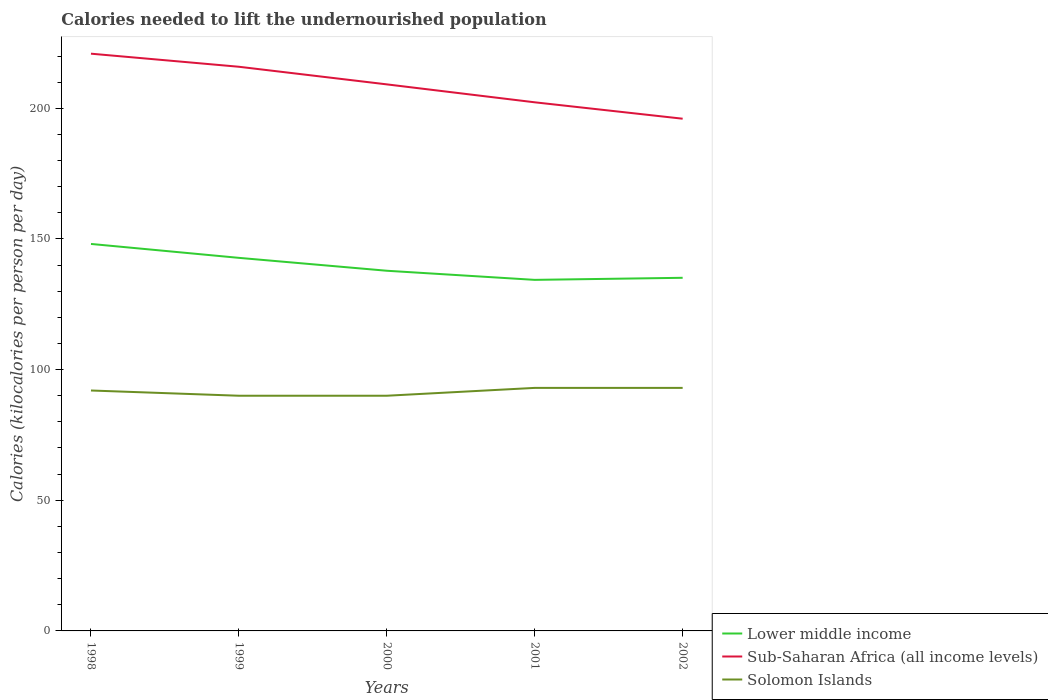Across all years, what is the maximum total calories needed to lift the undernourished population in Solomon Islands?
Provide a short and direct response. 90. What is the total total calories needed to lift the undernourished population in Sub-Saharan Africa (all income levels) in the graph?
Provide a succinct answer. 13.6. What is the difference between the highest and the second highest total calories needed to lift the undernourished population in Lower middle income?
Offer a very short reply. 13.74. Is the total calories needed to lift the undernourished population in Lower middle income strictly greater than the total calories needed to lift the undernourished population in Solomon Islands over the years?
Offer a terse response. No. How many lines are there?
Your answer should be compact. 3. How many years are there in the graph?
Your answer should be compact. 5. What is the difference between two consecutive major ticks on the Y-axis?
Your response must be concise. 50. Where does the legend appear in the graph?
Your response must be concise. Bottom right. How are the legend labels stacked?
Ensure brevity in your answer.  Vertical. What is the title of the graph?
Provide a short and direct response. Calories needed to lift the undernourished population. What is the label or title of the X-axis?
Your answer should be compact. Years. What is the label or title of the Y-axis?
Give a very brief answer. Calories (kilocalories per person per day). What is the Calories (kilocalories per person per day) in Lower middle income in 1998?
Give a very brief answer. 148.08. What is the Calories (kilocalories per person per day) in Sub-Saharan Africa (all income levels) in 1998?
Give a very brief answer. 220.89. What is the Calories (kilocalories per person per day) in Solomon Islands in 1998?
Offer a very short reply. 92. What is the Calories (kilocalories per person per day) in Lower middle income in 1999?
Give a very brief answer. 142.76. What is the Calories (kilocalories per person per day) of Sub-Saharan Africa (all income levels) in 1999?
Ensure brevity in your answer.  215.89. What is the Calories (kilocalories per person per day) in Solomon Islands in 1999?
Offer a very short reply. 90. What is the Calories (kilocalories per person per day) in Lower middle income in 2000?
Offer a terse response. 137.83. What is the Calories (kilocalories per person per day) in Sub-Saharan Africa (all income levels) in 2000?
Offer a very short reply. 209.15. What is the Calories (kilocalories per person per day) of Lower middle income in 2001?
Ensure brevity in your answer.  134.34. What is the Calories (kilocalories per person per day) in Sub-Saharan Africa (all income levels) in 2001?
Your answer should be compact. 202.29. What is the Calories (kilocalories per person per day) in Solomon Islands in 2001?
Offer a terse response. 93. What is the Calories (kilocalories per person per day) of Lower middle income in 2002?
Your response must be concise. 135.13. What is the Calories (kilocalories per person per day) of Sub-Saharan Africa (all income levels) in 2002?
Provide a short and direct response. 196.01. What is the Calories (kilocalories per person per day) of Solomon Islands in 2002?
Ensure brevity in your answer.  93. Across all years, what is the maximum Calories (kilocalories per person per day) of Lower middle income?
Ensure brevity in your answer.  148.08. Across all years, what is the maximum Calories (kilocalories per person per day) in Sub-Saharan Africa (all income levels)?
Your answer should be very brief. 220.89. Across all years, what is the maximum Calories (kilocalories per person per day) of Solomon Islands?
Ensure brevity in your answer.  93. Across all years, what is the minimum Calories (kilocalories per person per day) of Lower middle income?
Offer a very short reply. 134.34. Across all years, what is the minimum Calories (kilocalories per person per day) of Sub-Saharan Africa (all income levels)?
Make the answer very short. 196.01. What is the total Calories (kilocalories per person per day) of Lower middle income in the graph?
Provide a succinct answer. 698.13. What is the total Calories (kilocalories per person per day) of Sub-Saharan Africa (all income levels) in the graph?
Ensure brevity in your answer.  1044.22. What is the total Calories (kilocalories per person per day) in Solomon Islands in the graph?
Keep it short and to the point. 458. What is the difference between the Calories (kilocalories per person per day) in Lower middle income in 1998 and that in 1999?
Provide a short and direct response. 5.32. What is the difference between the Calories (kilocalories per person per day) in Sub-Saharan Africa (all income levels) in 1998 and that in 1999?
Your answer should be very brief. 5.01. What is the difference between the Calories (kilocalories per person per day) in Solomon Islands in 1998 and that in 1999?
Your answer should be very brief. 2. What is the difference between the Calories (kilocalories per person per day) in Lower middle income in 1998 and that in 2000?
Offer a very short reply. 10.26. What is the difference between the Calories (kilocalories per person per day) in Sub-Saharan Africa (all income levels) in 1998 and that in 2000?
Give a very brief answer. 11.75. What is the difference between the Calories (kilocalories per person per day) in Lower middle income in 1998 and that in 2001?
Your response must be concise. 13.74. What is the difference between the Calories (kilocalories per person per day) in Sub-Saharan Africa (all income levels) in 1998 and that in 2001?
Make the answer very short. 18.61. What is the difference between the Calories (kilocalories per person per day) in Lower middle income in 1998 and that in 2002?
Your answer should be compact. 12.95. What is the difference between the Calories (kilocalories per person per day) in Sub-Saharan Africa (all income levels) in 1998 and that in 2002?
Provide a succinct answer. 24.89. What is the difference between the Calories (kilocalories per person per day) of Lower middle income in 1999 and that in 2000?
Offer a terse response. 4.94. What is the difference between the Calories (kilocalories per person per day) of Sub-Saharan Africa (all income levels) in 1999 and that in 2000?
Ensure brevity in your answer.  6.74. What is the difference between the Calories (kilocalories per person per day) of Solomon Islands in 1999 and that in 2000?
Make the answer very short. 0. What is the difference between the Calories (kilocalories per person per day) of Lower middle income in 1999 and that in 2001?
Keep it short and to the point. 8.42. What is the difference between the Calories (kilocalories per person per day) of Sub-Saharan Africa (all income levels) in 1999 and that in 2001?
Provide a short and direct response. 13.6. What is the difference between the Calories (kilocalories per person per day) in Solomon Islands in 1999 and that in 2001?
Keep it short and to the point. -3. What is the difference between the Calories (kilocalories per person per day) in Lower middle income in 1999 and that in 2002?
Your answer should be compact. 7.63. What is the difference between the Calories (kilocalories per person per day) in Sub-Saharan Africa (all income levels) in 1999 and that in 2002?
Offer a very short reply. 19.88. What is the difference between the Calories (kilocalories per person per day) of Lower middle income in 2000 and that in 2001?
Give a very brief answer. 3.49. What is the difference between the Calories (kilocalories per person per day) of Sub-Saharan Africa (all income levels) in 2000 and that in 2001?
Give a very brief answer. 6.86. What is the difference between the Calories (kilocalories per person per day) in Lower middle income in 2000 and that in 2002?
Offer a terse response. 2.7. What is the difference between the Calories (kilocalories per person per day) in Sub-Saharan Africa (all income levels) in 2000 and that in 2002?
Make the answer very short. 13.14. What is the difference between the Calories (kilocalories per person per day) of Solomon Islands in 2000 and that in 2002?
Keep it short and to the point. -3. What is the difference between the Calories (kilocalories per person per day) of Lower middle income in 2001 and that in 2002?
Ensure brevity in your answer.  -0.79. What is the difference between the Calories (kilocalories per person per day) in Sub-Saharan Africa (all income levels) in 2001 and that in 2002?
Make the answer very short. 6.28. What is the difference between the Calories (kilocalories per person per day) of Lower middle income in 1998 and the Calories (kilocalories per person per day) of Sub-Saharan Africa (all income levels) in 1999?
Provide a short and direct response. -67.8. What is the difference between the Calories (kilocalories per person per day) in Lower middle income in 1998 and the Calories (kilocalories per person per day) in Solomon Islands in 1999?
Give a very brief answer. 58.08. What is the difference between the Calories (kilocalories per person per day) of Sub-Saharan Africa (all income levels) in 1998 and the Calories (kilocalories per person per day) of Solomon Islands in 1999?
Give a very brief answer. 130.89. What is the difference between the Calories (kilocalories per person per day) in Lower middle income in 1998 and the Calories (kilocalories per person per day) in Sub-Saharan Africa (all income levels) in 2000?
Provide a short and direct response. -61.06. What is the difference between the Calories (kilocalories per person per day) in Lower middle income in 1998 and the Calories (kilocalories per person per day) in Solomon Islands in 2000?
Your answer should be compact. 58.08. What is the difference between the Calories (kilocalories per person per day) of Sub-Saharan Africa (all income levels) in 1998 and the Calories (kilocalories per person per day) of Solomon Islands in 2000?
Your answer should be very brief. 130.89. What is the difference between the Calories (kilocalories per person per day) in Lower middle income in 1998 and the Calories (kilocalories per person per day) in Sub-Saharan Africa (all income levels) in 2001?
Your answer should be very brief. -54.2. What is the difference between the Calories (kilocalories per person per day) in Lower middle income in 1998 and the Calories (kilocalories per person per day) in Solomon Islands in 2001?
Give a very brief answer. 55.08. What is the difference between the Calories (kilocalories per person per day) in Sub-Saharan Africa (all income levels) in 1998 and the Calories (kilocalories per person per day) in Solomon Islands in 2001?
Offer a terse response. 127.89. What is the difference between the Calories (kilocalories per person per day) in Lower middle income in 1998 and the Calories (kilocalories per person per day) in Sub-Saharan Africa (all income levels) in 2002?
Keep it short and to the point. -47.92. What is the difference between the Calories (kilocalories per person per day) of Lower middle income in 1998 and the Calories (kilocalories per person per day) of Solomon Islands in 2002?
Offer a terse response. 55.08. What is the difference between the Calories (kilocalories per person per day) of Sub-Saharan Africa (all income levels) in 1998 and the Calories (kilocalories per person per day) of Solomon Islands in 2002?
Your answer should be very brief. 127.89. What is the difference between the Calories (kilocalories per person per day) of Lower middle income in 1999 and the Calories (kilocalories per person per day) of Sub-Saharan Africa (all income levels) in 2000?
Your response must be concise. -66.38. What is the difference between the Calories (kilocalories per person per day) of Lower middle income in 1999 and the Calories (kilocalories per person per day) of Solomon Islands in 2000?
Your answer should be compact. 52.76. What is the difference between the Calories (kilocalories per person per day) of Sub-Saharan Africa (all income levels) in 1999 and the Calories (kilocalories per person per day) of Solomon Islands in 2000?
Your answer should be very brief. 125.89. What is the difference between the Calories (kilocalories per person per day) of Lower middle income in 1999 and the Calories (kilocalories per person per day) of Sub-Saharan Africa (all income levels) in 2001?
Your answer should be compact. -59.53. What is the difference between the Calories (kilocalories per person per day) of Lower middle income in 1999 and the Calories (kilocalories per person per day) of Solomon Islands in 2001?
Ensure brevity in your answer.  49.76. What is the difference between the Calories (kilocalories per person per day) in Sub-Saharan Africa (all income levels) in 1999 and the Calories (kilocalories per person per day) in Solomon Islands in 2001?
Keep it short and to the point. 122.89. What is the difference between the Calories (kilocalories per person per day) in Lower middle income in 1999 and the Calories (kilocalories per person per day) in Sub-Saharan Africa (all income levels) in 2002?
Ensure brevity in your answer.  -53.25. What is the difference between the Calories (kilocalories per person per day) in Lower middle income in 1999 and the Calories (kilocalories per person per day) in Solomon Islands in 2002?
Give a very brief answer. 49.76. What is the difference between the Calories (kilocalories per person per day) in Sub-Saharan Africa (all income levels) in 1999 and the Calories (kilocalories per person per day) in Solomon Islands in 2002?
Give a very brief answer. 122.89. What is the difference between the Calories (kilocalories per person per day) in Lower middle income in 2000 and the Calories (kilocalories per person per day) in Sub-Saharan Africa (all income levels) in 2001?
Provide a succinct answer. -64.46. What is the difference between the Calories (kilocalories per person per day) of Lower middle income in 2000 and the Calories (kilocalories per person per day) of Solomon Islands in 2001?
Offer a terse response. 44.83. What is the difference between the Calories (kilocalories per person per day) in Sub-Saharan Africa (all income levels) in 2000 and the Calories (kilocalories per person per day) in Solomon Islands in 2001?
Ensure brevity in your answer.  116.15. What is the difference between the Calories (kilocalories per person per day) of Lower middle income in 2000 and the Calories (kilocalories per person per day) of Sub-Saharan Africa (all income levels) in 2002?
Give a very brief answer. -58.18. What is the difference between the Calories (kilocalories per person per day) of Lower middle income in 2000 and the Calories (kilocalories per person per day) of Solomon Islands in 2002?
Make the answer very short. 44.83. What is the difference between the Calories (kilocalories per person per day) of Sub-Saharan Africa (all income levels) in 2000 and the Calories (kilocalories per person per day) of Solomon Islands in 2002?
Make the answer very short. 116.15. What is the difference between the Calories (kilocalories per person per day) of Lower middle income in 2001 and the Calories (kilocalories per person per day) of Sub-Saharan Africa (all income levels) in 2002?
Ensure brevity in your answer.  -61.67. What is the difference between the Calories (kilocalories per person per day) in Lower middle income in 2001 and the Calories (kilocalories per person per day) in Solomon Islands in 2002?
Provide a short and direct response. 41.34. What is the difference between the Calories (kilocalories per person per day) in Sub-Saharan Africa (all income levels) in 2001 and the Calories (kilocalories per person per day) in Solomon Islands in 2002?
Your response must be concise. 109.29. What is the average Calories (kilocalories per person per day) in Lower middle income per year?
Make the answer very short. 139.63. What is the average Calories (kilocalories per person per day) in Sub-Saharan Africa (all income levels) per year?
Make the answer very short. 208.84. What is the average Calories (kilocalories per person per day) in Solomon Islands per year?
Make the answer very short. 91.6. In the year 1998, what is the difference between the Calories (kilocalories per person per day) in Lower middle income and Calories (kilocalories per person per day) in Sub-Saharan Africa (all income levels)?
Provide a short and direct response. -72.81. In the year 1998, what is the difference between the Calories (kilocalories per person per day) of Lower middle income and Calories (kilocalories per person per day) of Solomon Islands?
Provide a short and direct response. 56.08. In the year 1998, what is the difference between the Calories (kilocalories per person per day) of Sub-Saharan Africa (all income levels) and Calories (kilocalories per person per day) of Solomon Islands?
Give a very brief answer. 128.89. In the year 1999, what is the difference between the Calories (kilocalories per person per day) of Lower middle income and Calories (kilocalories per person per day) of Sub-Saharan Africa (all income levels)?
Ensure brevity in your answer.  -73.13. In the year 1999, what is the difference between the Calories (kilocalories per person per day) in Lower middle income and Calories (kilocalories per person per day) in Solomon Islands?
Your answer should be compact. 52.76. In the year 1999, what is the difference between the Calories (kilocalories per person per day) in Sub-Saharan Africa (all income levels) and Calories (kilocalories per person per day) in Solomon Islands?
Your response must be concise. 125.89. In the year 2000, what is the difference between the Calories (kilocalories per person per day) in Lower middle income and Calories (kilocalories per person per day) in Sub-Saharan Africa (all income levels)?
Provide a succinct answer. -71.32. In the year 2000, what is the difference between the Calories (kilocalories per person per day) of Lower middle income and Calories (kilocalories per person per day) of Solomon Islands?
Give a very brief answer. 47.83. In the year 2000, what is the difference between the Calories (kilocalories per person per day) in Sub-Saharan Africa (all income levels) and Calories (kilocalories per person per day) in Solomon Islands?
Your answer should be very brief. 119.15. In the year 2001, what is the difference between the Calories (kilocalories per person per day) in Lower middle income and Calories (kilocalories per person per day) in Sub-Saharan Africa (all income levels)?
Your answer should be very brief. -67.95. In the year 2001, what is the difference between the Calories (kilocalories per person per day) of Lower middle income and Calories (kilocalories per person per day) of Solomon Islands?
Provide a short and direct response. 41.34. In the year 2001, what is the difference between the Calories (kilocalories per person per day) of Sub-Saharan Africa (all income levels) and Calories (kilocalories per person per day) of Solomon Islands?
Provide a succinct answer. 109.29. In the year 2002, what is the difference between the Calories (kilocalories per person per day) in Lower middle income and Calories (kilocalories per person per day) in Sub-Saharan Africa (all income levels)?
Provide a short and direct response. -60.88. In the year 2002, what is the difference between the Calories (kilocalories per person per day) of Lower middle income and Calories (kilocalories per person per day) of Solomon Islands?
Offer a terse response. 42.13. In the year 2002, what is the difference between the Calories (kilocalories per person per day) in Sub-Saharan Africa (all income levels) and Calories (kilocalories per person per day) in Solomon Islands?
Your answer should be compact. 103.01. What is the ratio of the Calories (kilocalories per person per day) of Lower middle income in 1998 to that in 1999?
Your answer should be very brief. 1.04. What is the ratio of the Calories (kilocalories per person per day) of Sub-Saharan Africa (all income levels) in 1998 to that in 1999?
Ensure brevity in your answer.  1.02. What is the ratio of the Calories (kilocalories per person per day) of Solomon Islands in 1998 to that in 1999?
Offer a very short reply. 1.02. What is the ratio of the Calories (kilocalories per person per day) of Lower middle income in 1998 to that in 2000?
Offer a terse response. 1.07. What is the ratio of the Calories (kilocalories per person per day) of Sub-Saharan Africa (all income levels) in 1998 to that in 2000?
Provide a short and direct response. 1.06. What is the ratio of the Calories (kilocalories per person per day) in Solomon Islands in 1998 to that in 2000?
Offer a terse response. 1.02. What is the ratio of the Calories (kilocalories per person per day) of Lower middle income in 1998 to that in 2001?
Offer a terse response. 1.1. What is the ratio of the Calories (kilocalories per person per day) in Sub-Saharan Africa (all income levels) in 1998 to that in 2001?
Offer a very short reply. 1.09. What is the ratio of the Calories (kilocalories per person per day) in Lower middle income in 1998 to that in 2002?
Provide a succinct answer. 1.1. What is the ratio of the Calories (kilocalories per person per day) in Sub-Saharan Africa (all income levels) in 1998 to that in 2002?
Make the answer very short. 1.13. What is the ratio of the Calories (kilocalories per person per day) of Solomon Islands in 1998 to that in 2002?
Offer a terse response. 0.99. What is the ratio of the Calories (kilocalories per person per day) of Lower middle income in 1999 to that in 2000?
Offer a terse response. 1.04. What is the ratio of the Calories (kilocalories per person per day) in Sub-Saharan Africa (all income levels) in 1999 to that in 2000?
Offer a terse response. 1.03. What is the ratio of the Calories (kilocalories per person per day) in Solomon Islands in 1999 to that in 2000?
Make the answer very short. 1. What is the ratio of the Calories (kilocalories per person per day) in Lower middle income in 1999 to that in 2001?
Provide a short and direct response. 1.06. What is the ratio of the Calories (kilocalories per person per day) of Sub-Saharan Africa (all income levels) in 1999 to that in 2001?
Your answer should be very brief. 1.07. What is the ratio of the Calories (kilocalories per person per day) of Lower middle income in 1999 to that in 2002?
Your answer should be very brief. 1.06. What is the ratio of the Calories (kilocalories per person per day) of Sub-Saharan Africa (all income levels) in 1999 to that in 2002?
Offer a very short reply. 1.1. What is the ratio of the Calories (kilocalories per person per day) in Lower middle income in 2000 to that in 2001?
Your answer should be compact. 1.03. What is the ratio of the Calories (kilocalories per person per day) in Sub-Saharan Africa (all income levels) in 2000 to that in 2001?
Your response must be concise. 1.03. What is the ratio of the Calories (kilocalories per person per day) in Lower middle income in 2000 to that in 2002?
Provide a short and direct response. 1.02. What is the ratio of the Calories (kilocalories per person per day) of Sub-Saharan Africa (all income levels) in 2000 to that in 2002?
Ensure brevity in your answer.  1.07. What is the ratio of the Calories (kilocalories per person per day) of Solomon Islands in 2000 to that in 2002?
Provide a short and direct response. 0.97. What is the ratio of the Calories (kilocalories per person per day) of Sub-Saharan Africa (all income levels) in 2001 to that in 2002?
Your answer should be very brief. 1.03. What is the ratio of the Calories (kilocalories per person per day) in Solomon Islands in 2001 to that in 2002?
Your answer should be very brief. 1. What is the difference between the highest and the second highest Calories (kilocalories per person per day) in Lower middle income?
Provide a short and direct response. 5.32. What is the difference between the highest and the second highest Calories (kilocalories per person per day) in Sub-Saharan Africa (all income levels)?
Offer a very short reply. 5.01. What is the difference between the highest and the second highest Calories (kilocalories per person per day) in Solomon Islands?
Your answer should be compact. 0. What is the difference between the highest and the lowest Calories (kilocalories per person per day) of Lower middle income?
Ensure brevity in your answer.  13.74. What is the difference between the highest and the lowest Calories (kilocalories per person per day) in Sub-Saharan Africa (all income levels)?
Your response must be concise. 24.89. 